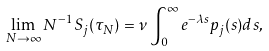Convert formula to latex. <formula><loc_0><loc_0><loc_500><loc_500>\lim _ { N \to \infty } N ^ { - 1 } S _ { j } ( \tau _ { N } ) = \nu \int _ { 0 } ^ { \infty } e ^ { - \lambda s } p _ { j } ( s ) d s ,</formula> 